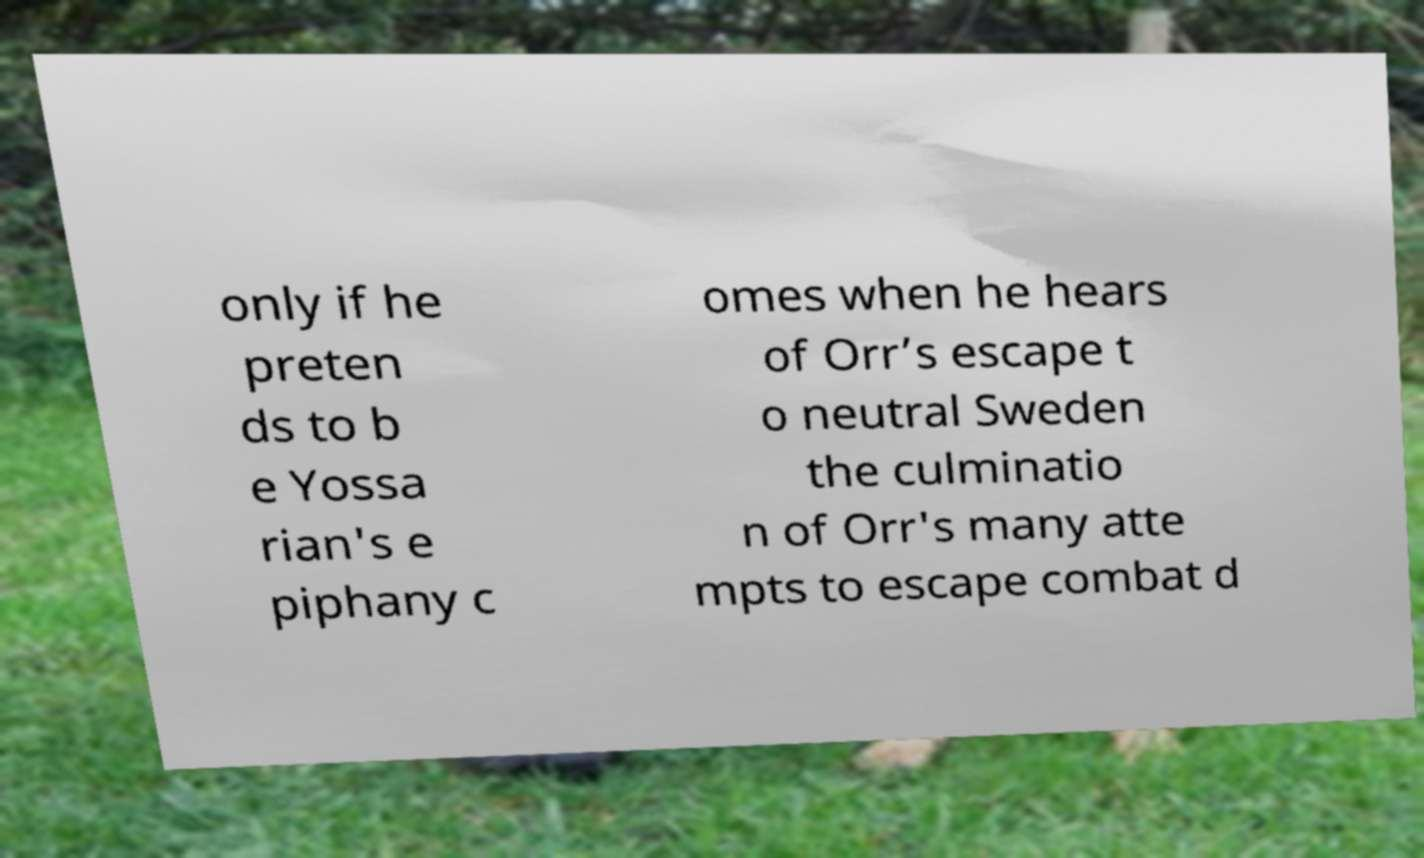Can you accurately transcribe the text from the provided image for me? only if he preten ds to b e Yossa rian's e piphany c omes when he hears of Orr’s escape t o neutral Sweden the culminatio n of Orr's many atte mpts to escape combat d 